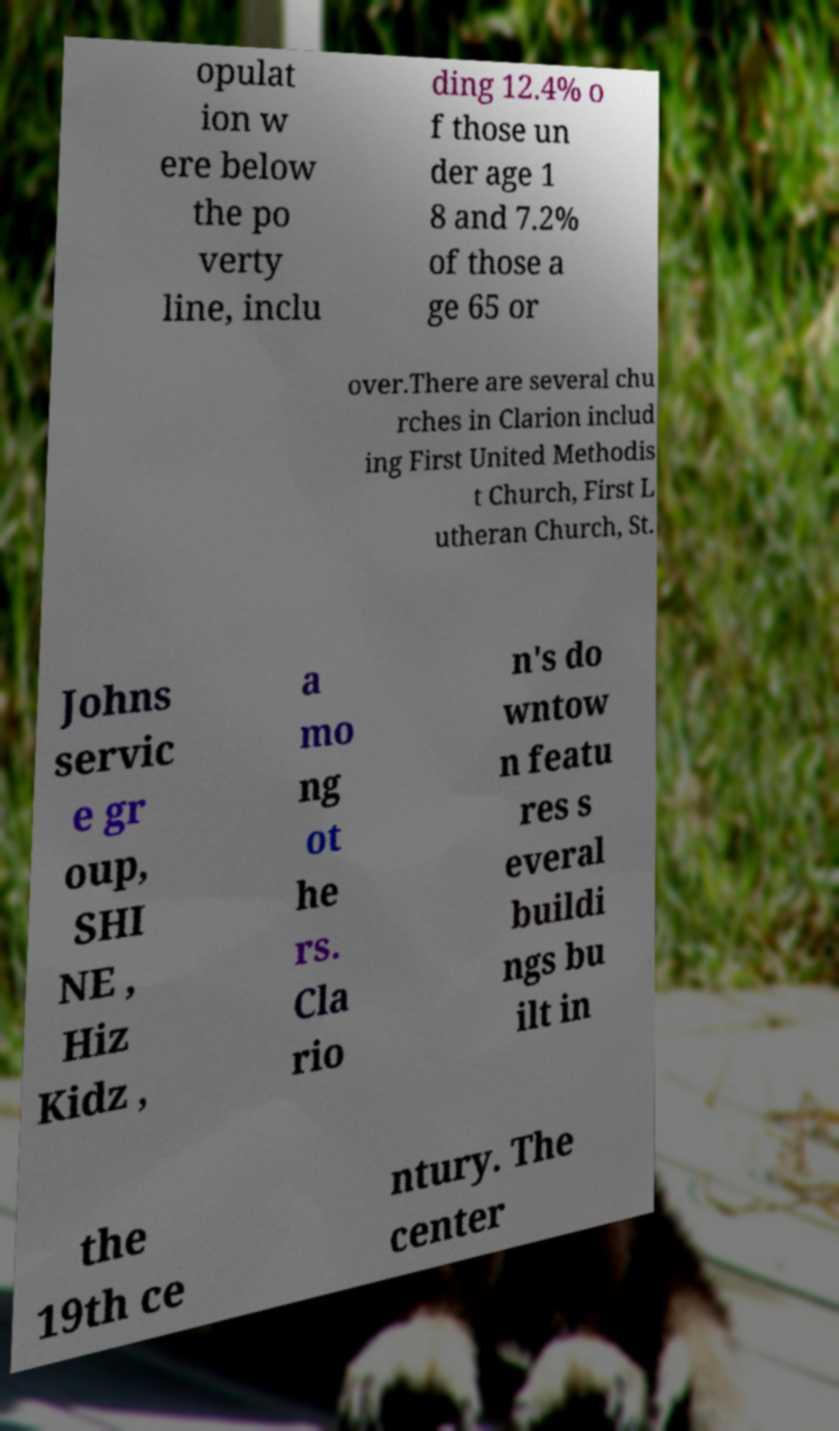Can you accurately transcribe the text from the provided image for me? opulat ion w ere below the po verty line, inclu ding 12.4% o f those un der age 1 8 and 7.2% of those a ge 65 or over.There are several chu rches in Clarion includ ing First United Methodis t Church, First L utheran Church, St. Johns servic e gr oup, SHI NE , Hiz Kidz , a mo ng ot he rs. Cla rio n's do wntow n featu res s everal buildi ngs bu ilt in the 19th ce ntury. The center 